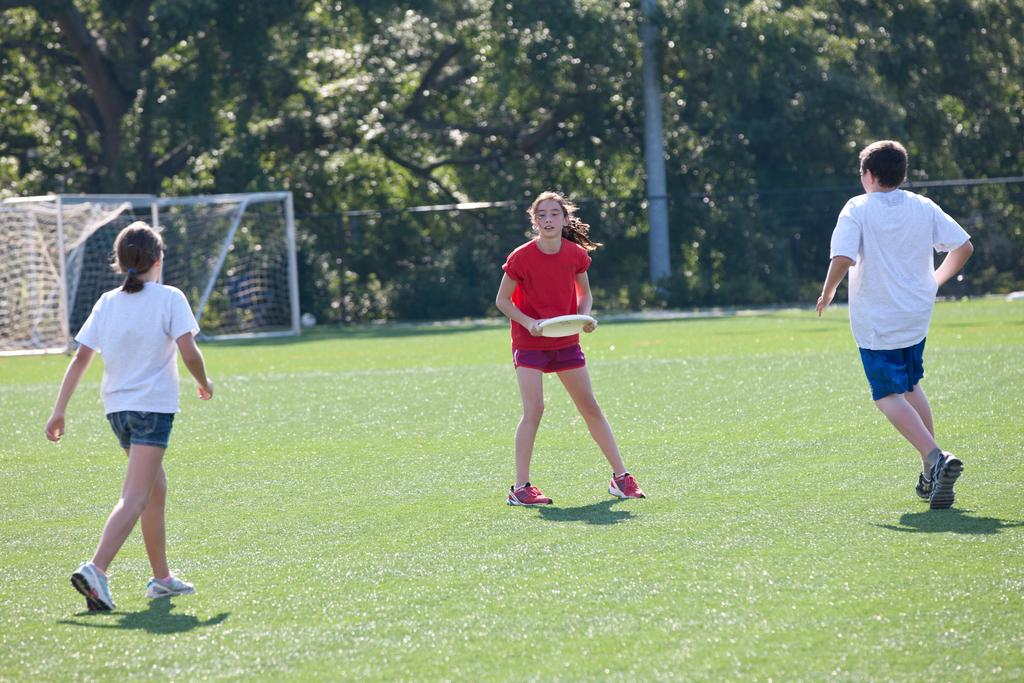What is the person in the image holding? The person is holding a disc in the image. How many people are present in the image? There are two people in the image. What type of material can be seen in the image? There is a mesh visible in the image. What type of natural environment is present in the image? There are trees in the image. What structure can be seen in the image? There is a pole in the image. What type of ink is used to write the verse on the disc in the image? There is no verse or ink present in the image; it only shows a person holding a disc and other elements like trees and a pole. How many frogs can be seen in the image? There are no frogs present in the image. 